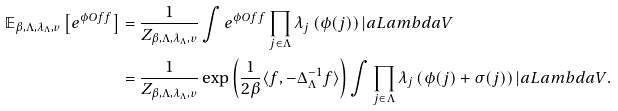<formula> <loc_0><loc_0><loc_500><loc_500>\mathbb { E } _ { \beta , \Lambda , \lambda _ { \Lambda } , v } \left [ e ^ { \phi O f { f } } \right ] & = \frac { 1 } { Z _ { \beta , \Lambda , \lambda _ { \Lambda } , v } } \int e ^ { \phi O f { f } } \prod _ { j \in \Lambda } \lambda _ { j } \left ( \phi ( j ) \right ) | a L a m b d a V \\ & = \frac { 1 } { Z _ { \beta , \Lambda , \lambda _ { \Lambda } , v } } \exp \left ( { \frac { 1 } { 2 \beta } \langle f , - \Delta _ { \Lambda } ^ { - 1 } f \rangle } \right ) \int \prod _ { j \in \Lambda } \lambda _ { j } \left ( \phi ( j ) + \sigma ( j ) \right ) | a L a m b d a V .</formula> 